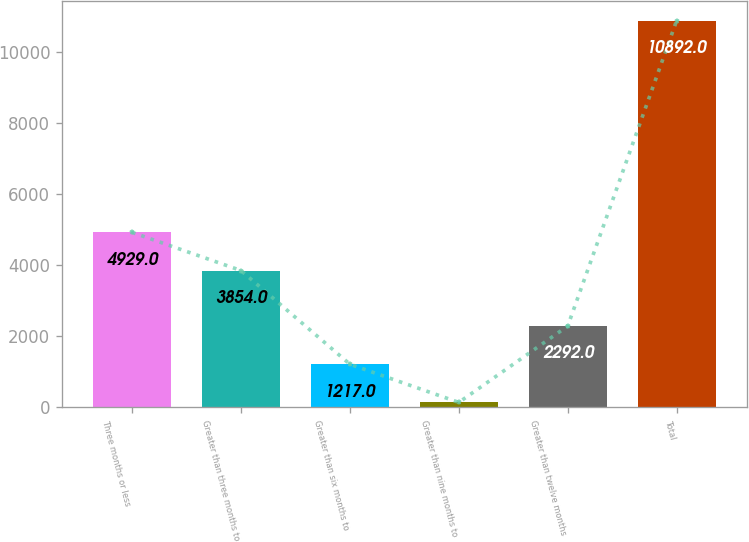<chart> <loc_0><loc_0><loc_500><loc_500><bar_chart><fcel>Three months or less<fcel>Greater than three months to<fcel>Greater than six months to<fcel>Greater than nine months to<fcel>Greater than twelve months<fcel>Total<nl><fcel>4929<fcel>3854<fcel>1217<fcel>142<fcel>2292<fcel>10892<nl></chart> 